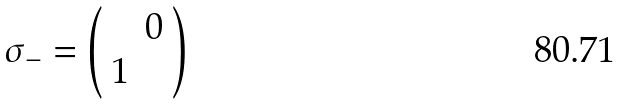Convert formula to latex. <formula><loc_0><loc_0><loc_500><loc_500>\sigma _ { - } = \left ( \begin{array} { c c } & 0 \\ 1 & \end{array} \right )</formula> 